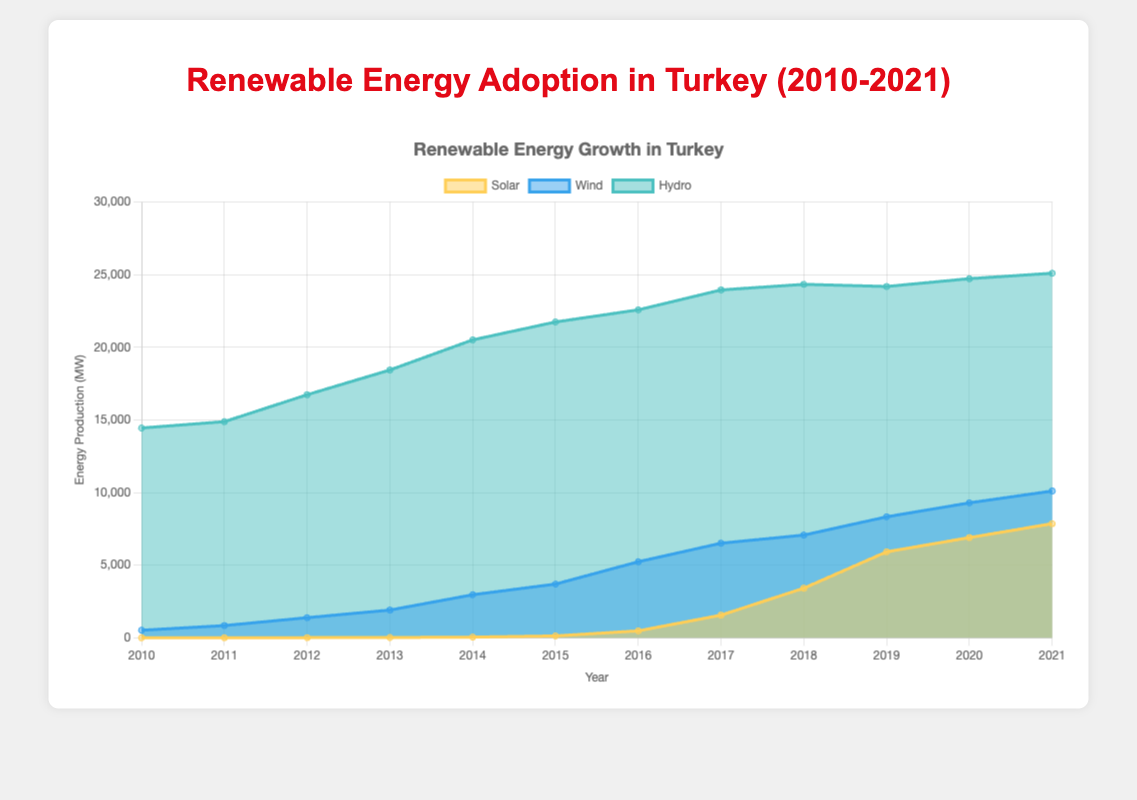What's the title of the chart? The title of the chart is displayed at the top and reads: "Renewable Energy Adoption in Turkey (2010-2021)"
Answer: Renewable Energy Adoption in Turkey (2010-2021) What are the three sources of renewable energy shown in the chart? The chart contains three datasets labeled as 'Solar', 'Wind', and 'Hydro', differentiated by their colors.
Answer: Solar, Wind, Hydro In which year does solar energy production first exceed 1000 MW? By examining the 'Solar' dataset trend, it is clear that solar energy production first exceeds 1000 MW in 2017.
Answer: 2017 What's the approximate amount of hydro energy produced in 2018? The value for hydro energy in 2018 can be directly read from the chart, which shows around 24,334 MW.
Answer: 24,334 MW What is the total renewable energy production (sum of solar, wind, and hydro) in 2014? Adding the respective values for solar (40 MW), wind (2,958 MW), and hydro (20,510 MW) in 2014 results in a total production of 23,508 MW.
Answer: 23,508 MW How does the growth of solar energy between 2016 and 2017 compare to its growth between 2017 and 2018? In 2016, solar energy production was 471 MW, and in 2017 it was 1,553 MW, growing by 1,082 MW. Between 2017 and 2018, it grew from 1,553 MW to 3,410 MW, growing by 1,857 MW. So the growth from 2017 to 2018 was significantly larger.
Answer: 2017 to 2018 growth was larger Which year experienced the highest wind energy production, and what was the value? From the ‘Wind’ dataset, the highest value for wind energy is 10,102 MW in 2021.
Answer: 2021, 10,102 MW How much did hydro energy production increase from 2010 to 2021? In 2010, hydro energy production was 14,442 MW, and in 2021 it was 25,100 MW. The increase is 25,100 MW - 14,442 MW = 10,658 MW.
Answer: 10,658 MW What is the overall trend for solar energy from 2010 to 2021? Solar energy starts at 0 MW in 2010 and rises steadily to 7,852 MW in 2021, indicating a strong upward trend.
Answer: Upward trend 